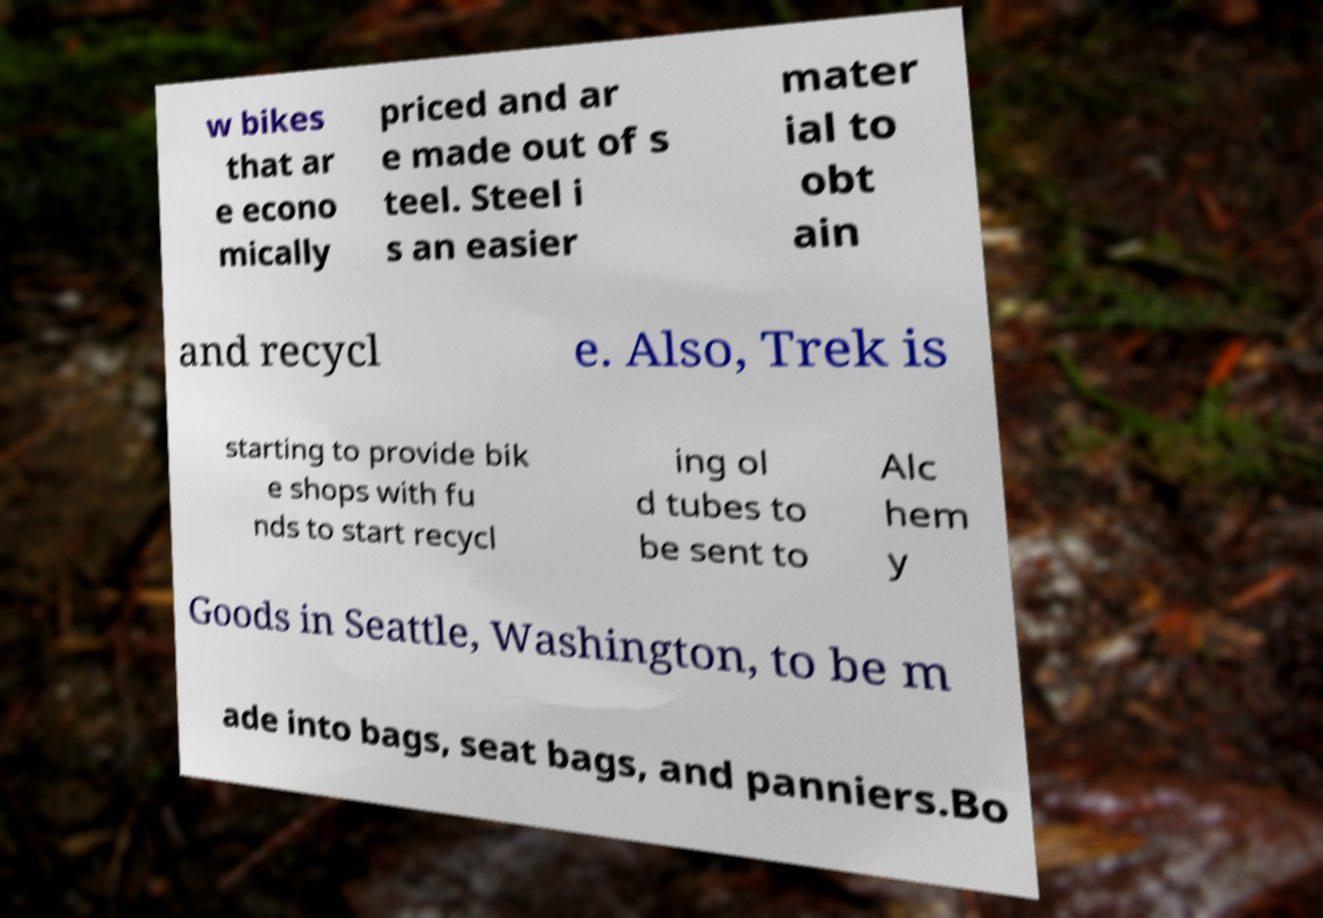There's text embedded in this image that I need extracted. Can you transcribe it verbatim? w bikes that ar e econo mically priced and ar e made out of s teel. Steel i s an easier mater ial to obt ain and recycl e. Also, Trek is starting to provide bik e shops with fu nds to start recycl ing ol d tubes to be sent to Alc hem y Goods in Seattle, Washington, to be m ade into bags, seat bags, and panniers.Bo 